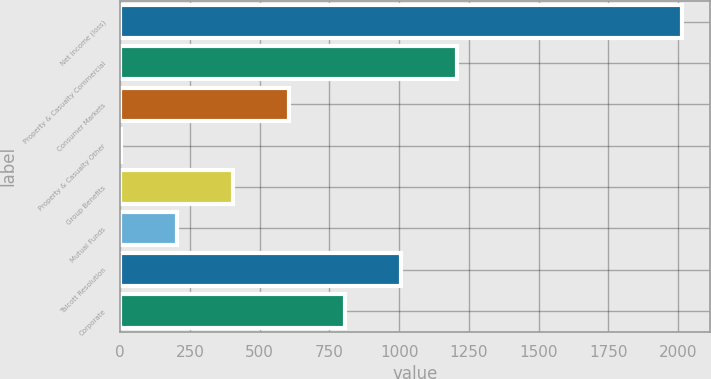Convert chart to OTSL. <chart><loc_0><loc_0><loc_500><loc_500><bar_chart><fcel>Net income (loss)<fcel>Property & Casualty Commercial<fcel>Consumer Markets<fcel>Property & Casualty Other<fcel>Group Benefits<fcel>Mutual Funds<fcel>Talcott Resolution<fcel>Corporate<nl><fcel>2013<fcel>1208.6<fcel>605.3<fcel>2<fcel>404.2<fcel>203.1<fcel>1007.5<fcel>806.4<nl></chart> 